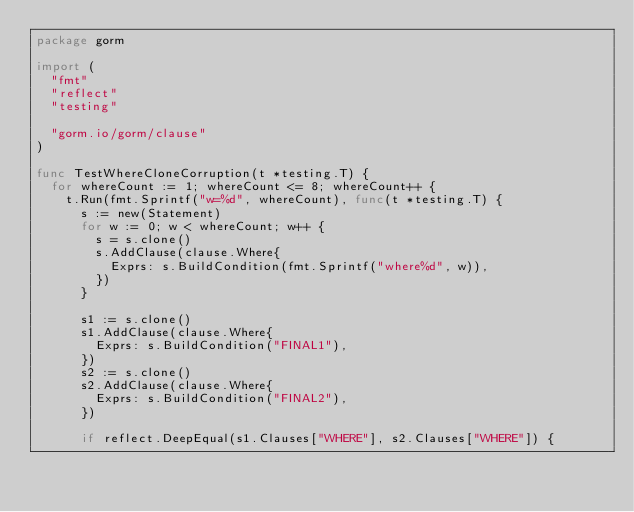Convert code to text. <code><loc_0><loc_0><loc_500><loc_500><_Go_>package gorm

import (
	"fmt"
	"reflect"
	"testing"

	"gorm.io/gorm/clause"
)

func TestWhereCloneCorruption(t *testing.T) {
	for whereCount := 1; whereCount <= 8; whereCount++ {
		t.Run(fmt.Sprintf("w=%d", whereCount), func(t *testing.T) {
			s := new(Statement)
			for w := 0; w < whereCount; w++ {
				s = s.clone()
				s.AddClause(clause.Where{
					Exprs: s.BuildCondition(fmt.Sprintf("where%d", w)),
				})
			}

			s1 := s.clone()
			s1.AddClause(clause.Where{
				Exprs: s.BuildCondition("FINAL1"),
			})
			s2 := s.clone()
			s2.AddClause(clause.Where{
				Exprs: s.BuildCondition("FINAL2"),
			})

			if reflect.DeepEqual(s1.Clauses["WHERE"], s2.Clauses["WHERE"]) {</code> 